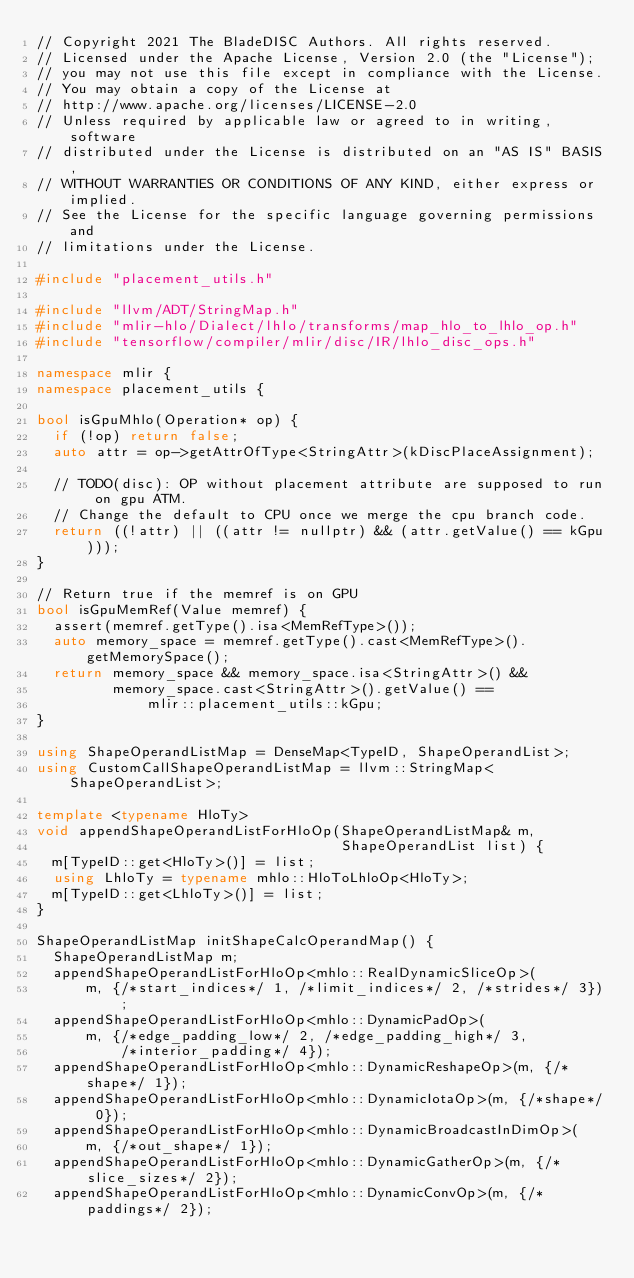<code> <loc_0><loc_0><loc_500><loc_500><_C++_>// Copyright 2021 The BladeDISC Authors. All rights reserved.
// Licensed under the Apache License, Version 2.0 (the "License");
// you may not use this file except in compliance with the License.
// You may obtain a copy of the License at
// http://www.apache.org/licenses/LICENSE-2.0
// Unless required by applicable law or agreed to in writing, software
// distributed under the License is distributed on an "AS IS" BASIS,
// WITHOUT WARRANTIES OR CONDITIONS OF ANY KIND, either express or implied.
// See the License for the specific language governing permissions and
// limitations under the License.

#include "placement_utils.h"

#include "llvm/ADT/StringMap.h"
#include "mlir-hlo/Dialect/lhlo/transforms/map_hlo_to_lhlo_op.h"
#include "tensorflow/compiler/mlir/disc/IR/lhlo_disc_ops.h"

namespace mlir {
namespace placement_utils {

bool isGpuMhlo(Operation* op) {
  if (!op) return false;
  auto attr = op->getAttrOfType<StringAttr>(kDiscPlaceAssignment);

  // TODO(disc): OP without placement attribute are supposed to run on gpu ATM.
  // Change the default to CPU once we merge the cpu branch code.
  return ((!attr) || ((attr != nullptr) && (attr.getValue() == kGpu)));
}

// Return true if the memref is on GPU
bool isGpuMemRef(Value memref) {
  assert(memref.getType().isa<MemRefType>());
  auto memory_space = memref.getType().cast<MemRefType>().getMemorySpace();
  return memory_space && memory_space.isa<StringAttr>() &&
         memory_space.cast<StringAttr>().getValue() ==
             mlir::placement_utils::kGpu;
}

using ShapeOperandListMap = DenseMap<TypeID, ShapeOperandList>;
using CustomCallShapeOperandListMap = llvm::StringMap<ShapeOperandList>;

template <typename HloTy>
void appendShapeOperandListForHloOp(ShapeOperandListMap& m,
                                    ShapeOperandList list) {
  m[TypeID::get<HloTy>()] = list;
  using LhloTy = typename mhlo::HloToLhloOp<HloTy>;
  m[TypeID::get<LhloTy>()] = list;
}

ShapeOperandListMap initShapeCalcOperandMap() {
  ShapeOperandListMap m;
  appendShapeOperandListForHloOp<mhlo::RealDynamicSliceOp>(
      m, {/*start_indices*/ 1, /*limit_indices*/ 2, /*strides*/ 3});
  appendShapeOperandListForHloOp<mhlo::DynamicPadOp>(
      m, {/*edge_padding_low*/ 2, /*edge_padding_high*/ 3,
          /*interior_padding*/ 4});
  appendShapeOperandListForHloOp<mhlo::DynamicReshapeOp>(m, {/*shape*/ 1});
  appendShapeOperandListForHloOp<mhlo::DynamicIotaOp>(m, {/*shape*/ 0});
  appendShapeOperandListForHloOp<mhlo::DynamicBroadcastInDimOp>(
      m, {/*out_shape*/ 1});
  appendShapeOperandListForHloOp<mhlo::DynamicGatherOp>(m, {/*slice_sizes*/ 2});
  appendShapeOperandListForHloOp<mhlo::DynamicConvOp>(m, {/*paddings*/ 2});</code> 